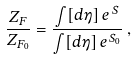Convert formula to latex. <formula><loc_0><loc_0><loc_500><loc_500>\frac { Z _ { F } } { Z _ { F _ { 0 } } } = \frac { \int [ d \eta ] \, e ^ { \, S } } { \int [ d \eta ] \, e ^ { \, S _ { 0 } } } \, ,</formula> 